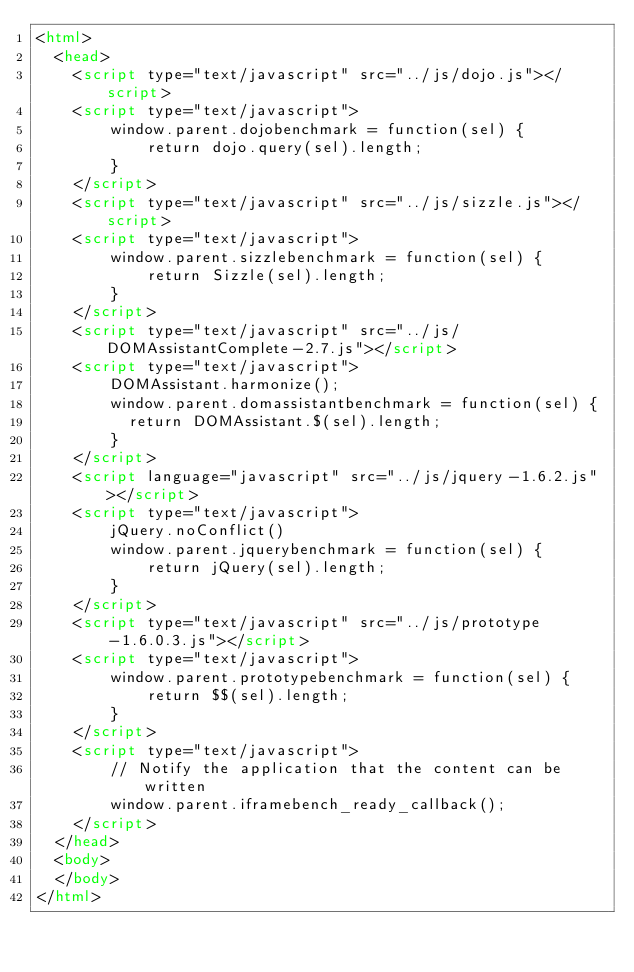<code> <loc_0><loc_0><loc_500><loc_500><_HTML_><html>
  <head>
    <script type="text/javascript" src="../js/dojo.js"></script>
    <script type="text/javascript">
        window.parent.dojobenchmark = function(sel) {
            return dojo.query(sel).length;
        }
    </script>
    <script type="text/javascript" src="../js/sizzle.js"></script>
    <script type="text/javascript">
        window.parent.sizzlebenchmark = function(sel) {
            return Sizzle(sel).length;
        }
    </script>
    <script type="text/javascript" src="../js/DOMAssistantComplete-2.7.js"></script>
    <script type="text/javascript">
        DOMAssistant.harmonize();
        window.parent.domassistantbenchmark = function(sel) {
        	return DOMAssistant.$(sel).length;
        }
    </script>
    <script language="javascript" src="../js/jquery-1.6.2.js"></script>
    <script type="text/javascript">
        jQuery.noConflict()
        window.parent.jquerybenchmark = function(sel) {
            return jQuery(sel).length;
        }
    </script>
    <script type="text/javascript" src="../js/prototype-1.6.0.3.js"></script>
    <script type="text/javascript">
        window.parent.prototypebenchmark = function(sel) {
            return $$(sel).length;
        }
    </script>
    <script type="text/javascript">
        // Notify the application that the content can be written
        window.parent.iframebench_ready_callback();
    </script>
  </head>
  <body>
  </body>
</html>
</code> 